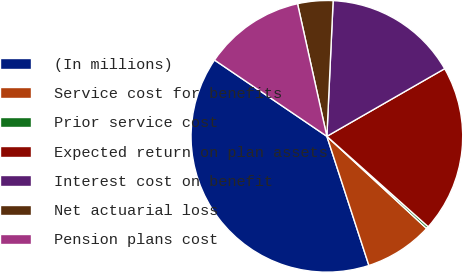<chart> <loc_0><loc_0><loc_500><loc_500><pie_chart><fcel>(In millions)<fcel>Service cost for benefits<fcel>Prior service cost<fcel>Expected return on plan assets<fcel>Interest cost on benefit<fcel>Net actuarial loss<fcel>Pension plans cost<nl><fcel>39.5%<fcel>8.12%<fcel>0.28%<fcel>19.89%<fcel>15.97%<fcel>4.2%<fcel>12.04%<nl></chart> 